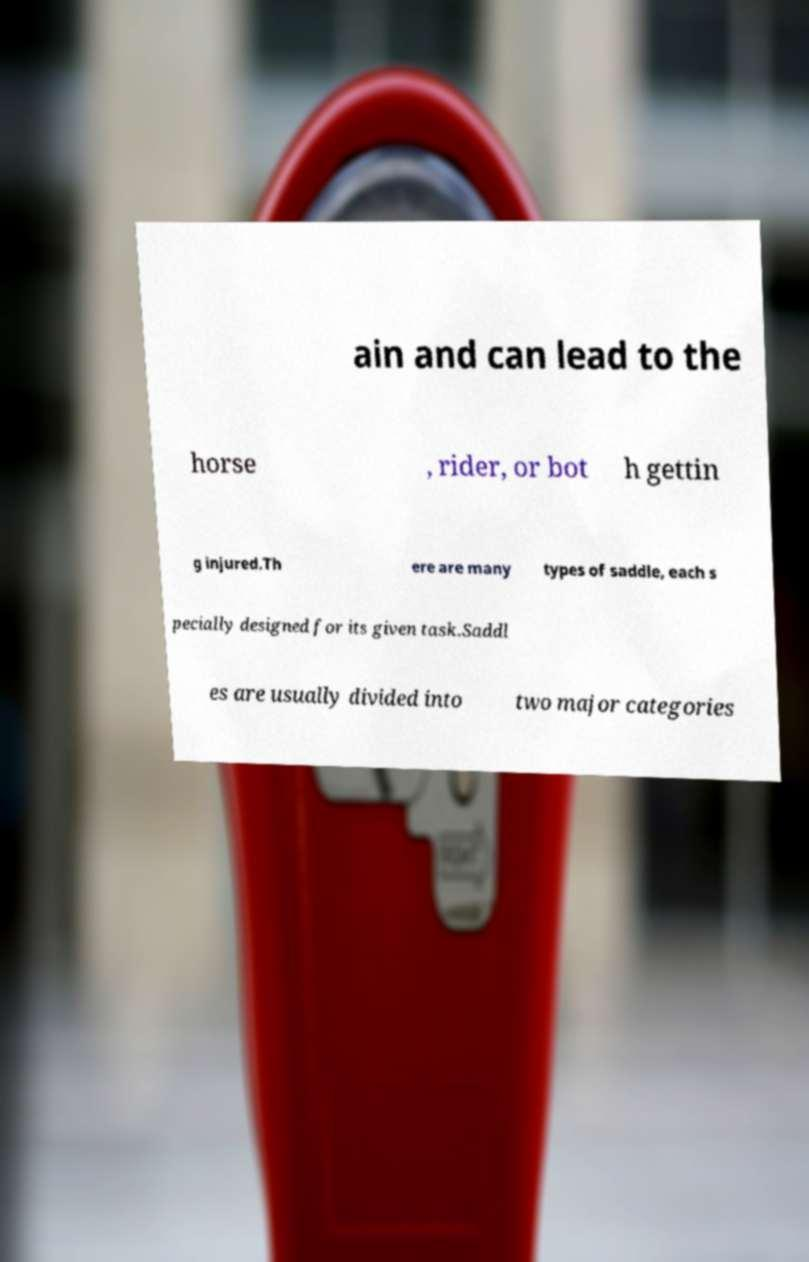I need the written content from this picture converted into text. Can you do that? ain and can lead to the horse , rider, or bot h gettin g injured.Th ere are many types of saddle, each s pecially designed for its given task.Saddl es are usually divided into two major categories 